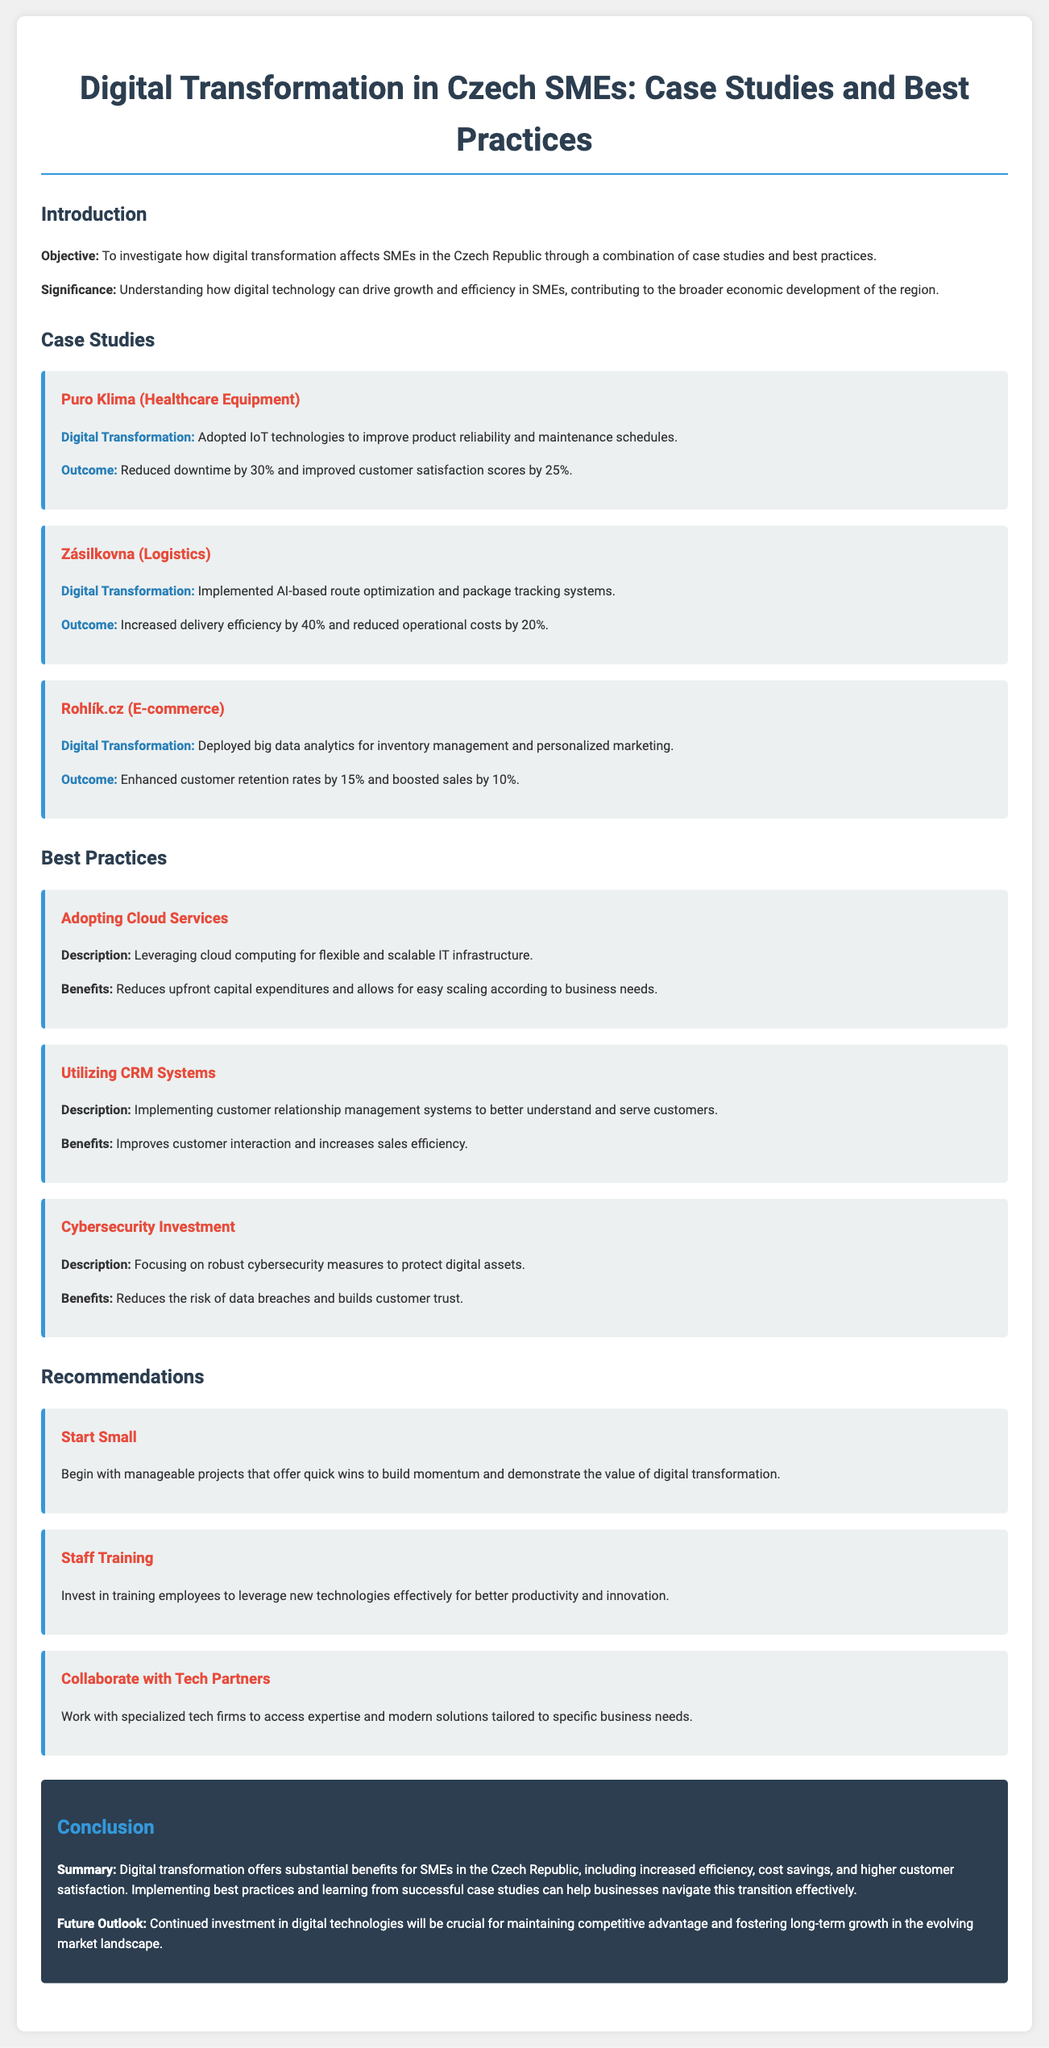What was the main objective of the study? The objective of the study is mentioned in the introduction section, focusing on investigating the effects of digital transformation on SMEs in the Czech Republic.
Answer: Investigate how digital transformation affects SMEs in the Czech Republic How much did Puro Klima reduce downtime by? This information is provided in the case study section for Puro Klima, highlighting the outcome of their digital transformation efforts.
Answer: 30% What technology did Zásilkovna implement for route optimization? The case study for Zásilkovna specifies the technology they used for improving their logistics operations.
Answer: AI-based route optimization What is one benefit of adopting cloud services? The benefits of cloud services are listed under best practices, providing a specific advantage of using this technology.
Answer: Reduces upfront capital expenditures What is a key recommendation for SMEs starting digital transformation? The recommendations section provides guidance on initial steps that SMEs can take to begin their digital transformation journey.
Answer: Start Small What was the outcome of Rohlík.cz's digital transformation in terms of sales? The outcome for Rohlík.cz in the case study highlights the financial impact of their digital transformation.
Answer: Boosted sales by 10% Which best practice is focused on protecting digital assets? The best practices section identifies specific strategies for SMEs, particularly focusing on securing digital information.
Answer: Cybersecurity Investment What aspect of future investment is crucial for SMEs according to the conclusion? The conclusion discusses the importance of a particular type of investment for maintaining competitiveness in the future.
Answer: Continued investment in digital technologies 